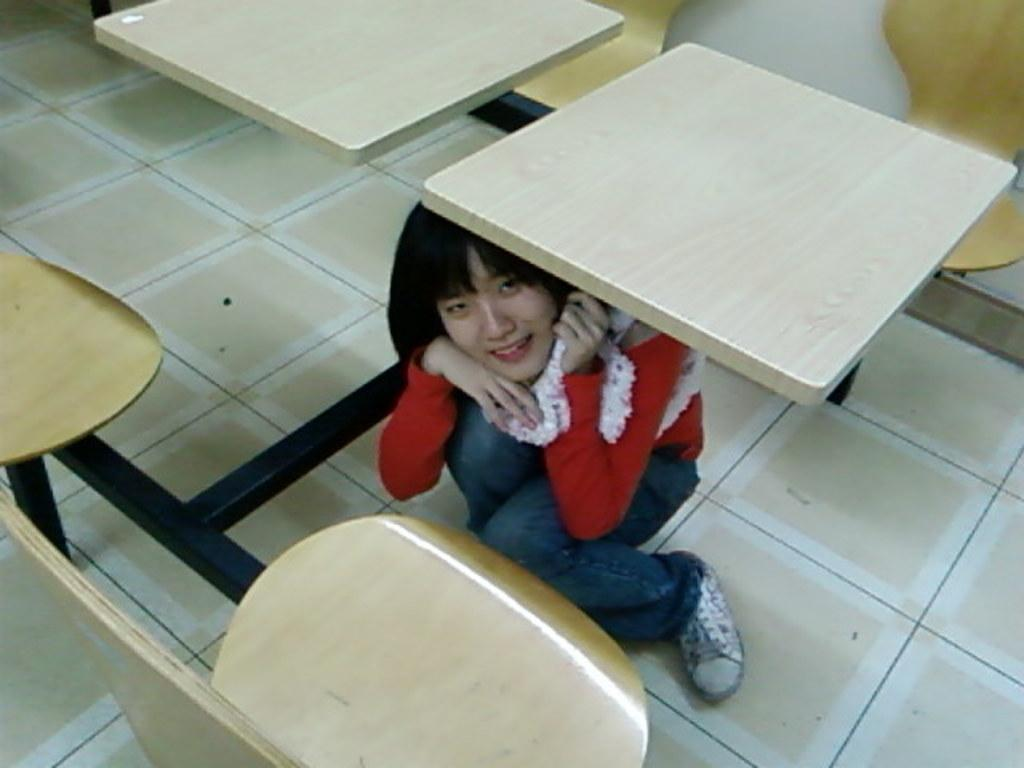Who is the main subject in the image? There is a girl in the image. What is the girl wearing? The girl is wearing a red t-shirt and blue jeans. Where is the girl sitting in the image? The girl is sitting under a wooden bench. What other furniture is present in the image? There is a bench and yellow chairs in the image. What type of wilderness can be seen in the background of the image? There is no wilderness visible in the image; it is focused on the girl and the furniture. What kind of marble is used to make the chairs in the image? There are no chairs made of marble in the image; the chairs are yellow and made of a different material. 